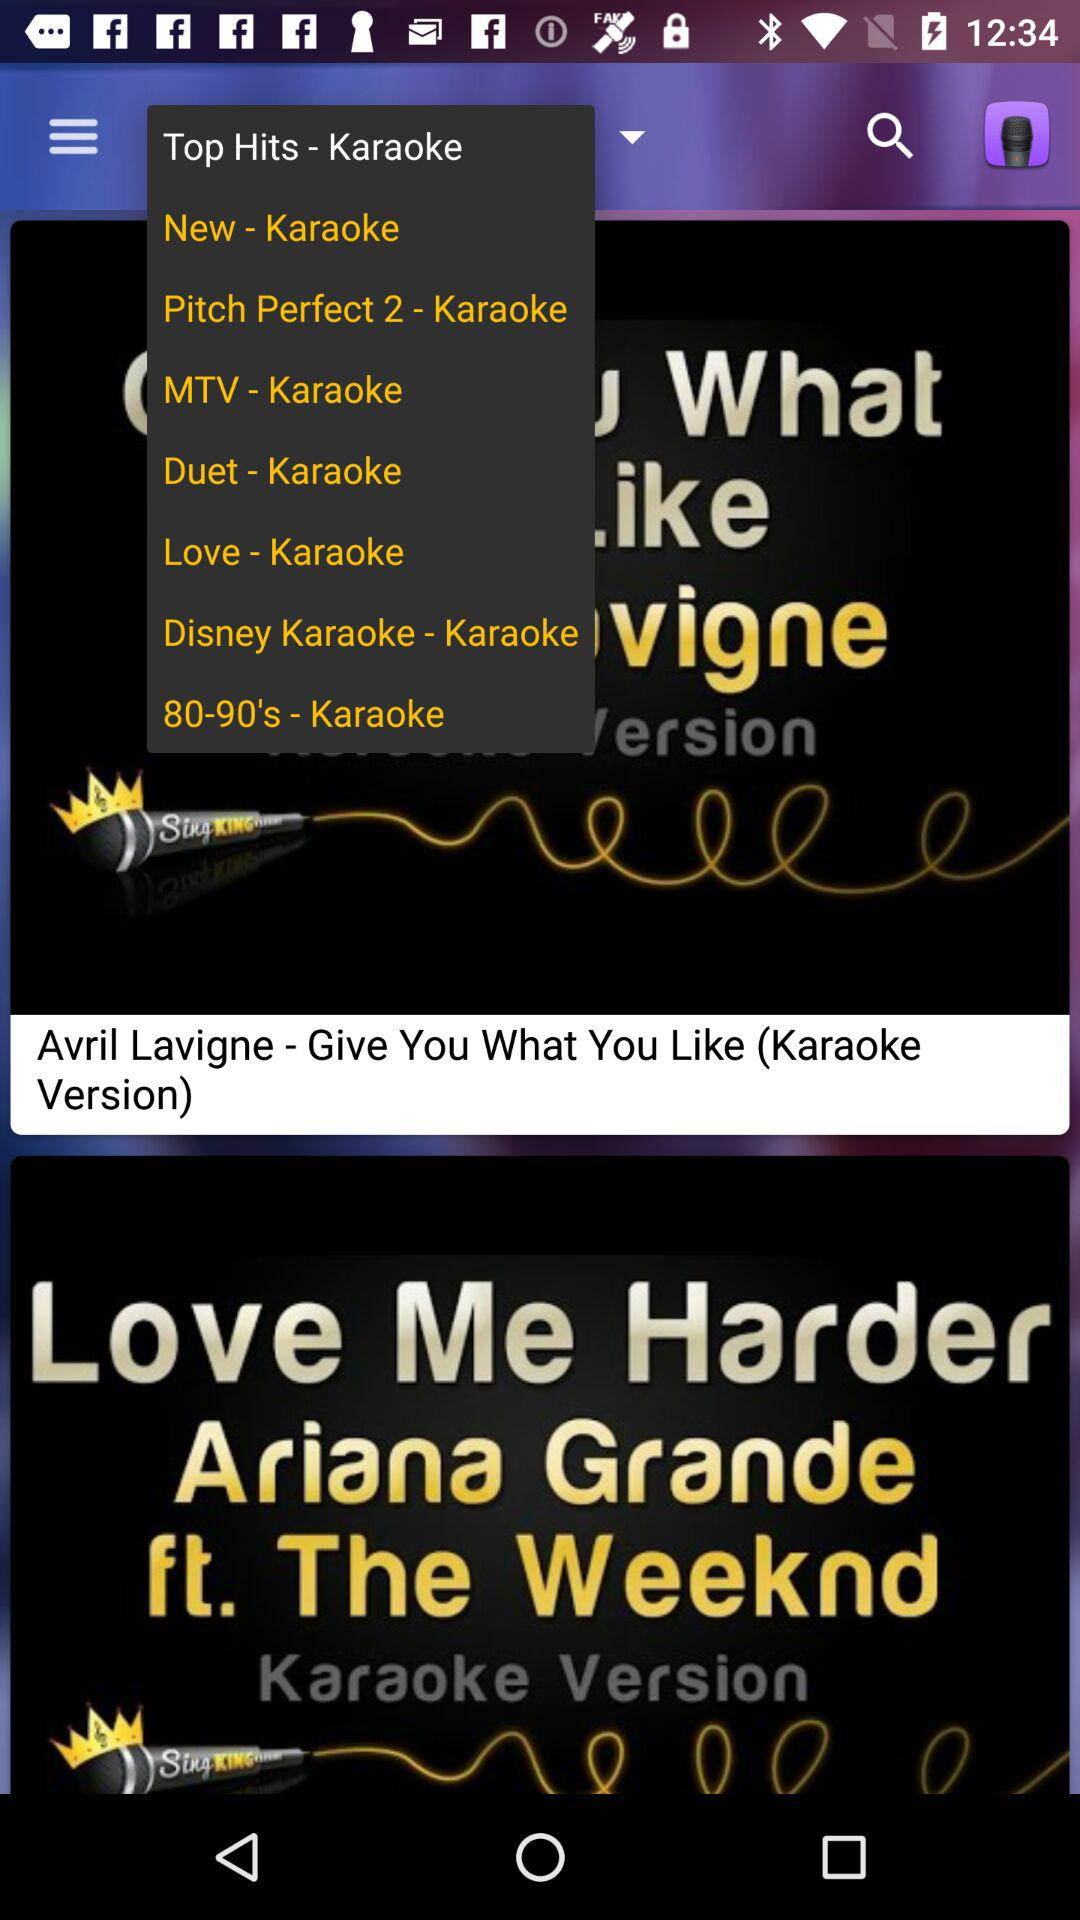Who's the singer of the song "Give You What You Like"? The singer of the song is Avril Lavigne. 